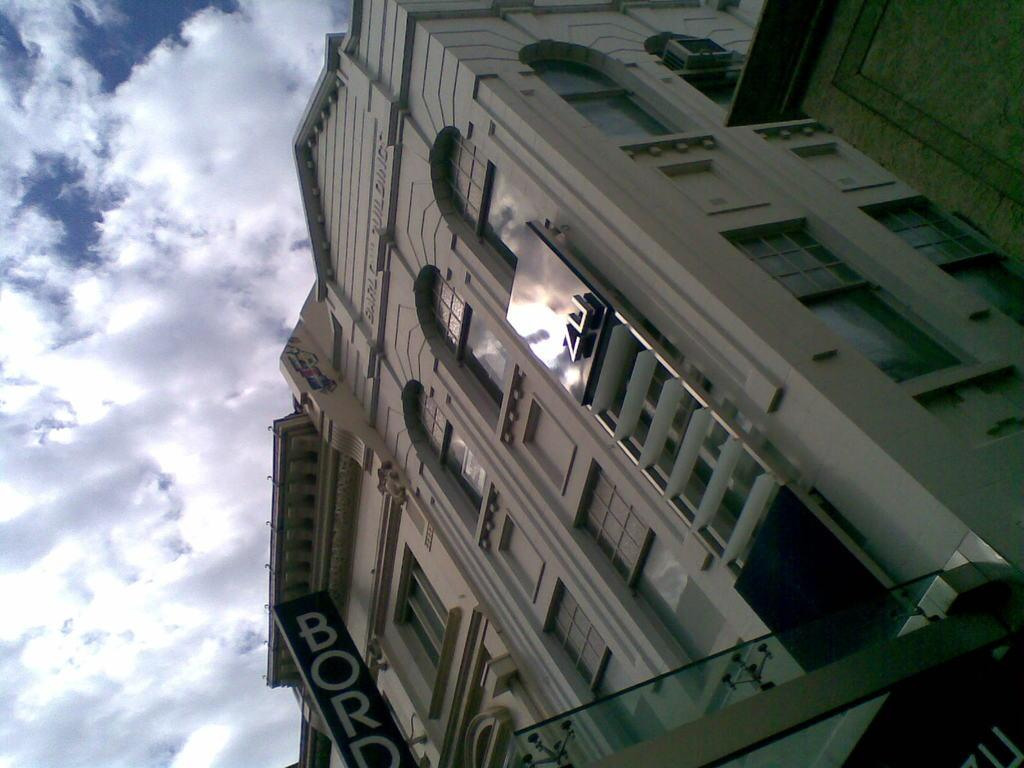What is located in the center of the image? There are buildings in the center of the image. What is at the bottom of the image? There is a board at the bottom of the image. What can be seen in the background of the image? The sky is visible in the background of the image. How many eyes can be seen on the buildings in the image? There are no eyes present on the buildings in the image. What type of space is depicted in the image? The image does not depict any specific space; it shows buildings, a board, and the sky. 